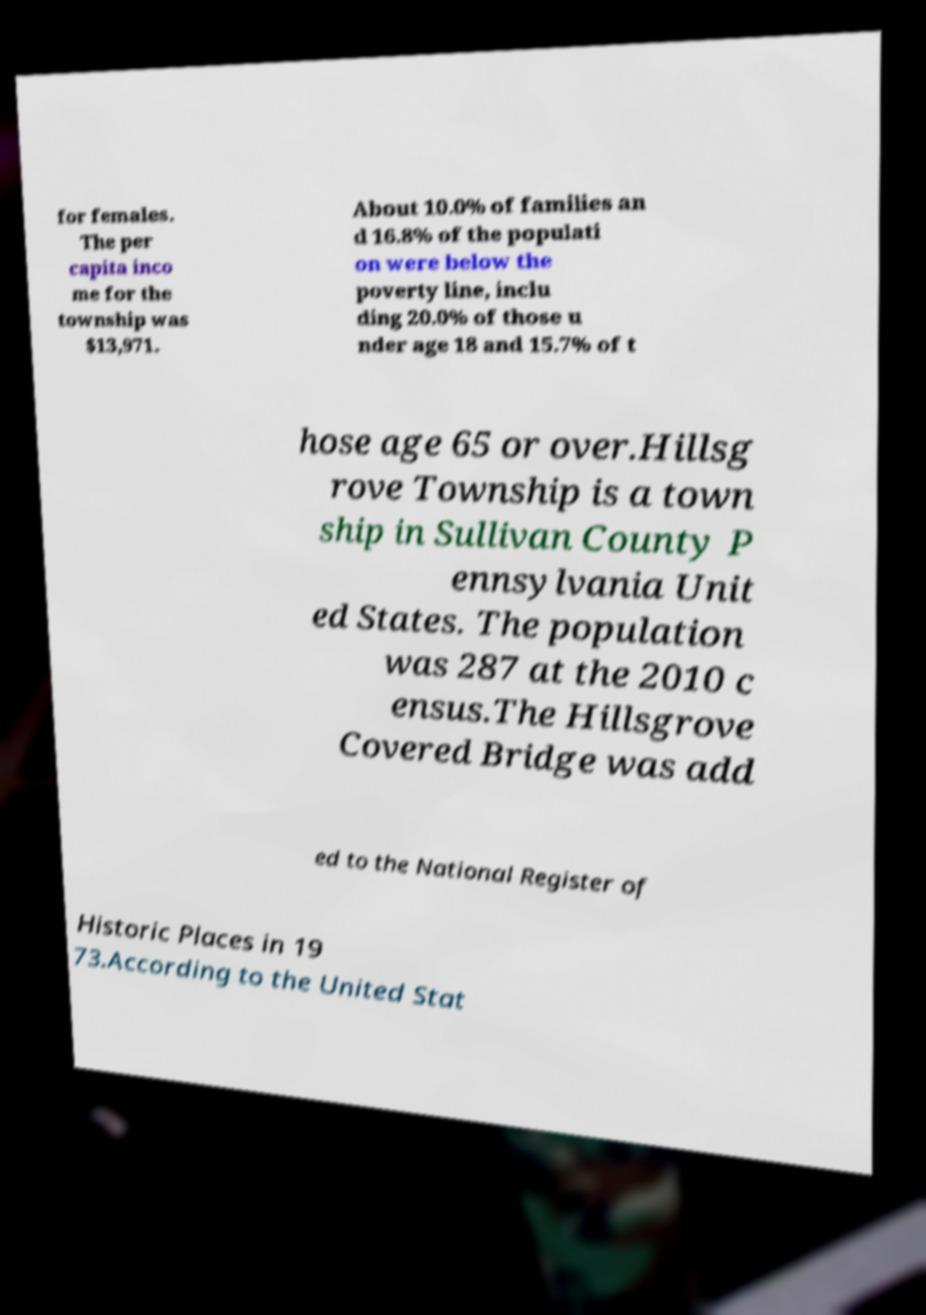For documentation purposes, I need the text within this image transcribed. Could you provide that? for females. The per capita inco me for the township was $13,971. About 10.0% of families an d 16.8% of the populati on were below the poverty line, inclu ding 20.0% of those u nder age 18 and 15.7% of t hose age 65 or over.Hillsg rove Township is a town ship in Sullivan County P ennsylvania Unit ed States. The population was 287 at the 2010 c ensus.The Hillsgrove Covered Bridge was add ed to the National Register of Historic Places in 19 73.According to the United Stat 